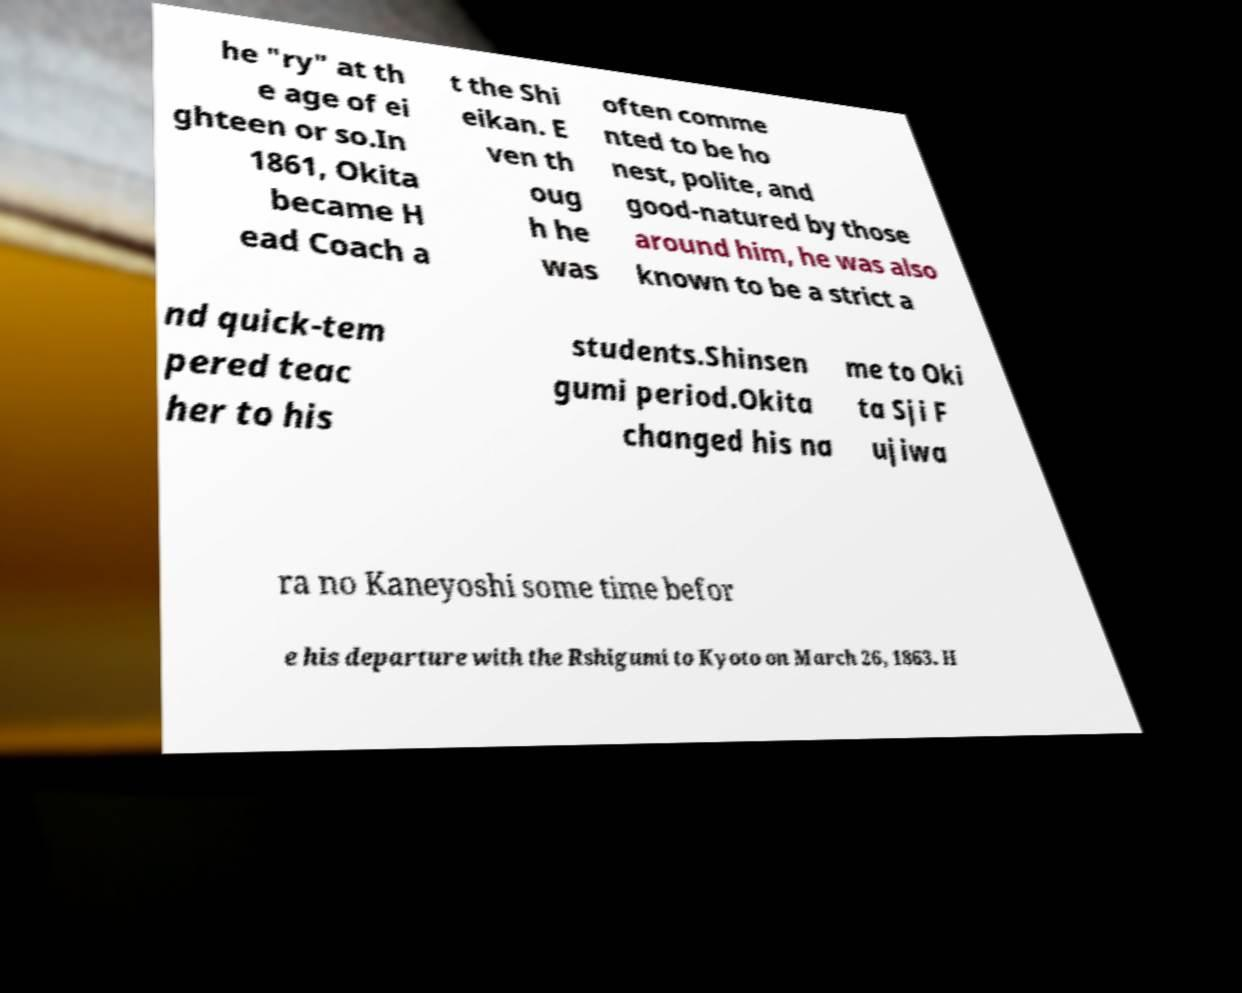I need the written content from this picture converted into text. Can you do that? he "ry" at th e age of ei ghteen or so.In 1861, Okita became H ead Coach a t the Shi eikan. E ven th oug h he was often comme nted to be ho nest, polite, and good-natured by those around him, he was also known to be a strict a nd quick-tem pered teac her to his students.Shinsen gumi period.Okita changed his na me to Oki ta Sji F ujiwa ra no Kaneyoshi some time befor e his departure with the Rshigumi to Kyoto on March 26, 1863. H 